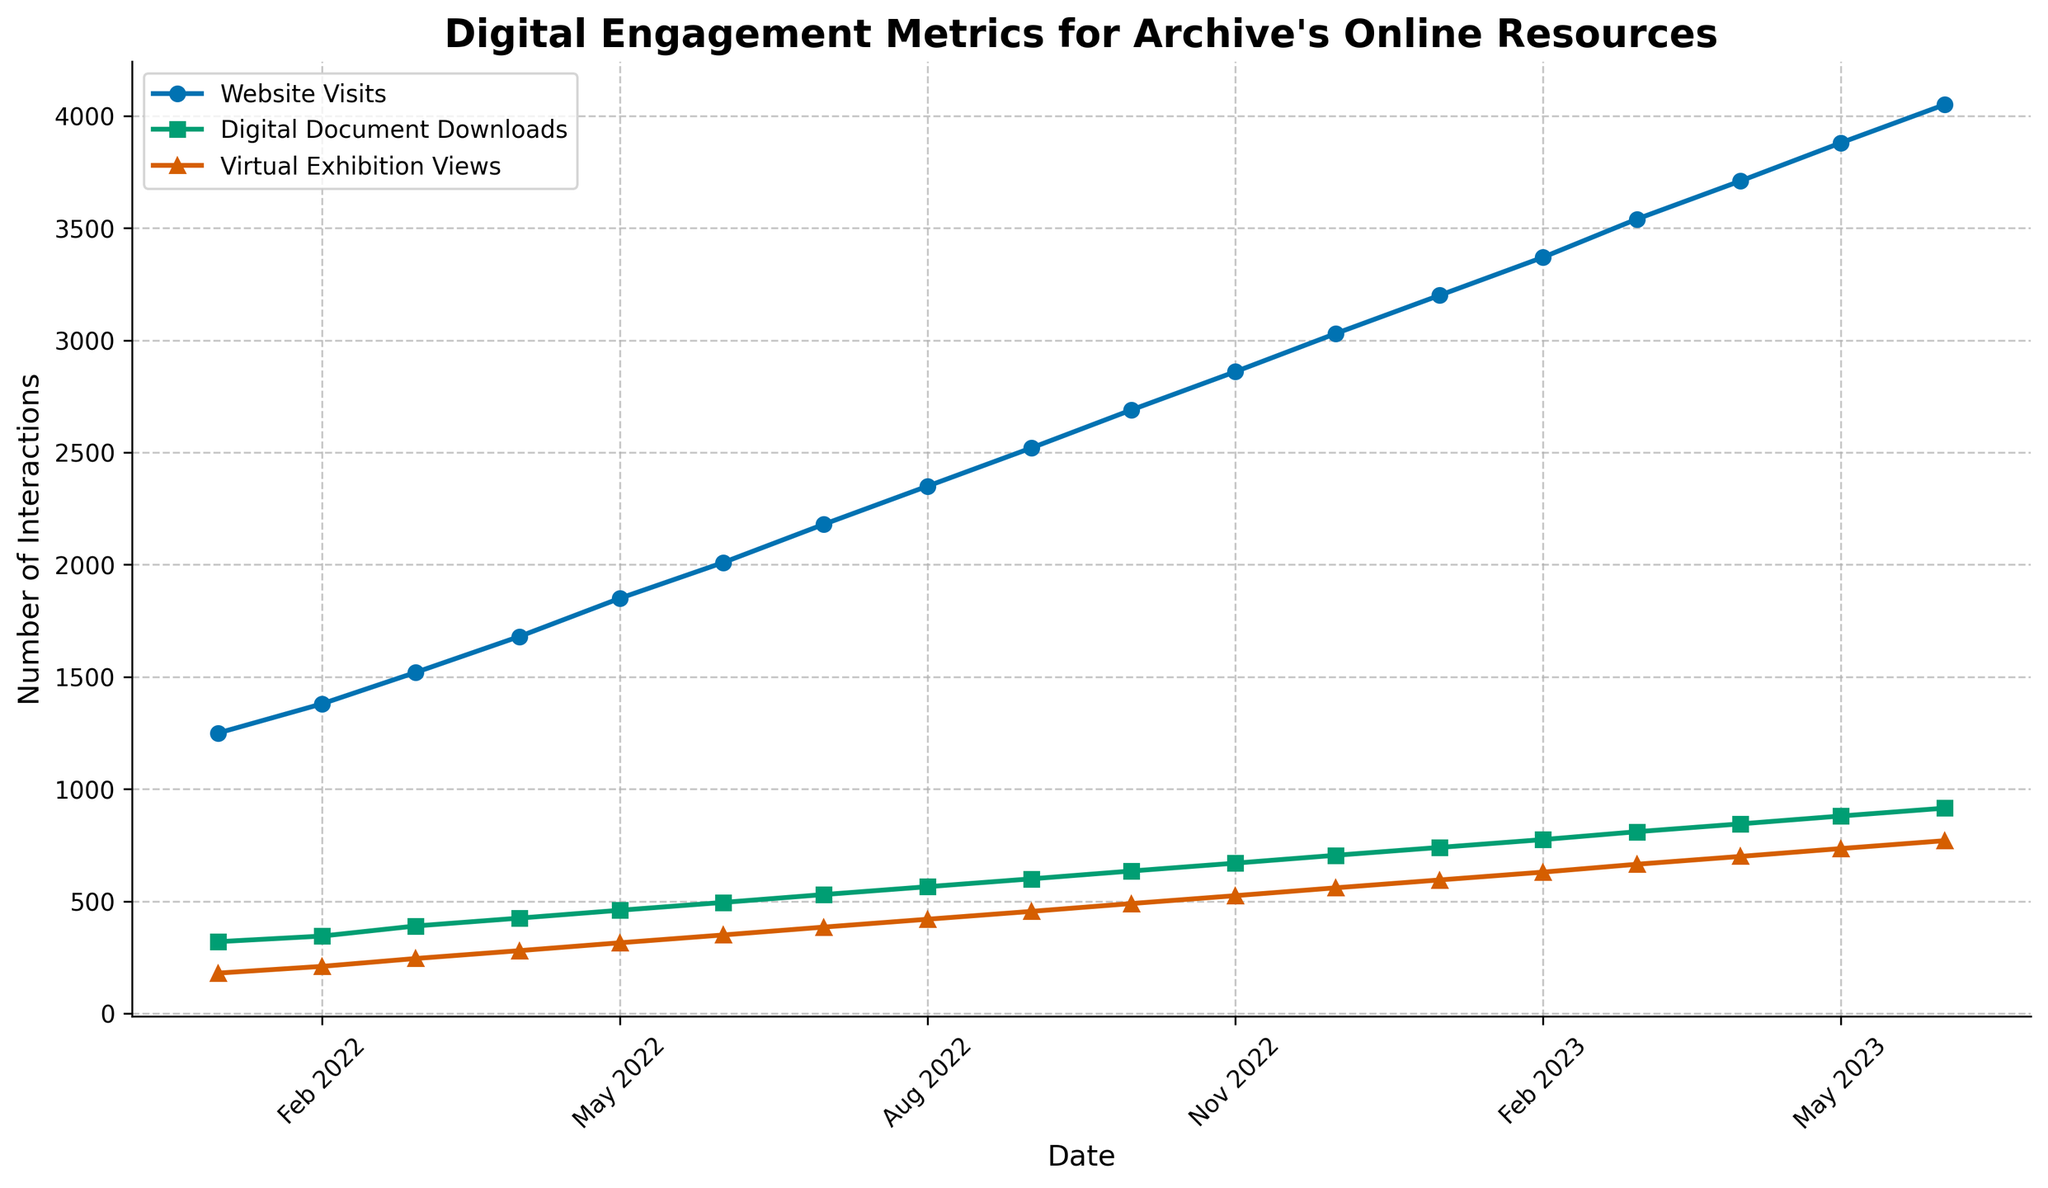How has the trend for website visits changed from January 2022 to June 2023? To determine the trend, look at the line representing website visits over the entire period from January 2022 to June 2023. Observe the overall direction of the line.
Answer: It has increased consistently How do digital document downloads in December 2022 compare to those in January 2023? To compare digital document downloads between two months, locate the data points for December 2022 and January 2023 on the line for digital document downloads and compare the values. December 2022 has 705 downloads, and January 2023 has 740 downloads.
Answer: January 2023 has more What is the average number of virtual exhibition views for the period from January to April 2022? To find the average, sum the values for virtual exhibition views from January to April 2022 (180 + 210 + 245 + 280) and divide by the number of months (4).
Answer: 228.75 Which digital engagement metric experienced the highest growth rate from January 2022 to June 2023? To identify the highest growth rate, compare the starting and end values for each metric: Website Visits (1250 to 4050), Digital Document Downloads (320 to 915), Virtual Exhibition Views (180 to 770). The growth for each is 2800, 595, and 590, respectively.
Answer: Website Visits What color represents the line for virtual exhibition views, and how does it compare to the color of the website visits line? Observe the colors of the lines in the legend. Virtual exhibition views are marked with a different symbol (^) and color than website visits. Identify these colors visually.
Answer: Virtual exhibition views are blue, website visits are an orange/red hue In which month did digital document downloads cross the 600 mark? To identify when digital document downloads crossed 600, follow the line for digital document downloads and find the month where it first exceeds 600.
Answer: September 2022 Rank the metrics in terms of the number of interactions in June 2023. Compare the values for each metric in June 2023: Website Visits (4050), Digital Document Downloads (915), Virtual Exhibition Views (770), and order them accordingly.
Answer: Website Visits > Digital Document Downloads > Virtual Exhibition Views What is the total number of website visits recorded from January 2022 to June 2023? Sum all the website visit values from January 2022 (1250) through June 2023 (4050) using the given data points.
Answer: 50700 By how much did virtual exhibition views increase from January 2023 to June 2023? To calculate the increase, subtract the virtual exhibition views in January 2023 (595) from those in June 2023 (770). The increase is 770 - 595.
Answer: 175 Which metric shows the most variability throughout the period? To determine the metric with most variability, visually compare the fluctuation lengths and steepness of the lines. Website Visits show the steepest increase over time.
Answer: Website Visits 